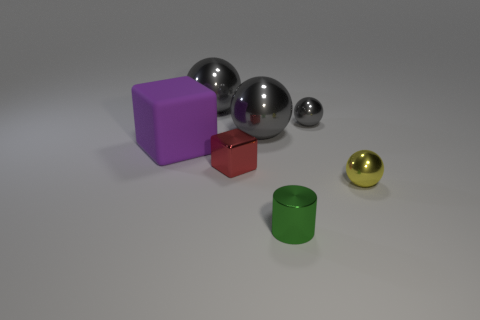The small yellow object that is made of the same material as the cylinder is what shape?
Your response must be concise. Sphere. Are there any other things that have the same shape as the small green object?
Make the answer very short. No. How many big matte objects are to the left of the rubber object?
Your answer should be compact. 0. Is there a brown cylinder?
Give a very brief answer. No. There is a large object that is in front of the large gray sphere in front of the metallic object that is behind the small gray thing; what is its color?
Provide a short and direct response. Purple. There is a small shiny ball on the left side of the yellow sphere; is there a gray metal sphere that is in front of it?
Offer a very short reply. Yes. Does the small metal sphere to the left of the yellow ball have the same color as the metallic object that is left of the red block?
Your answer should be very brief. Yes. What number of gray balls are the same size as the purple object?
Offer a very short reply. 2. Is the size of the gray metal thing that is right of the green shiny object the same as the big purple matte thing?
Offer a terse response. No. There is a yellow object; what shape is it?
Make the answer very short. Sphere. 